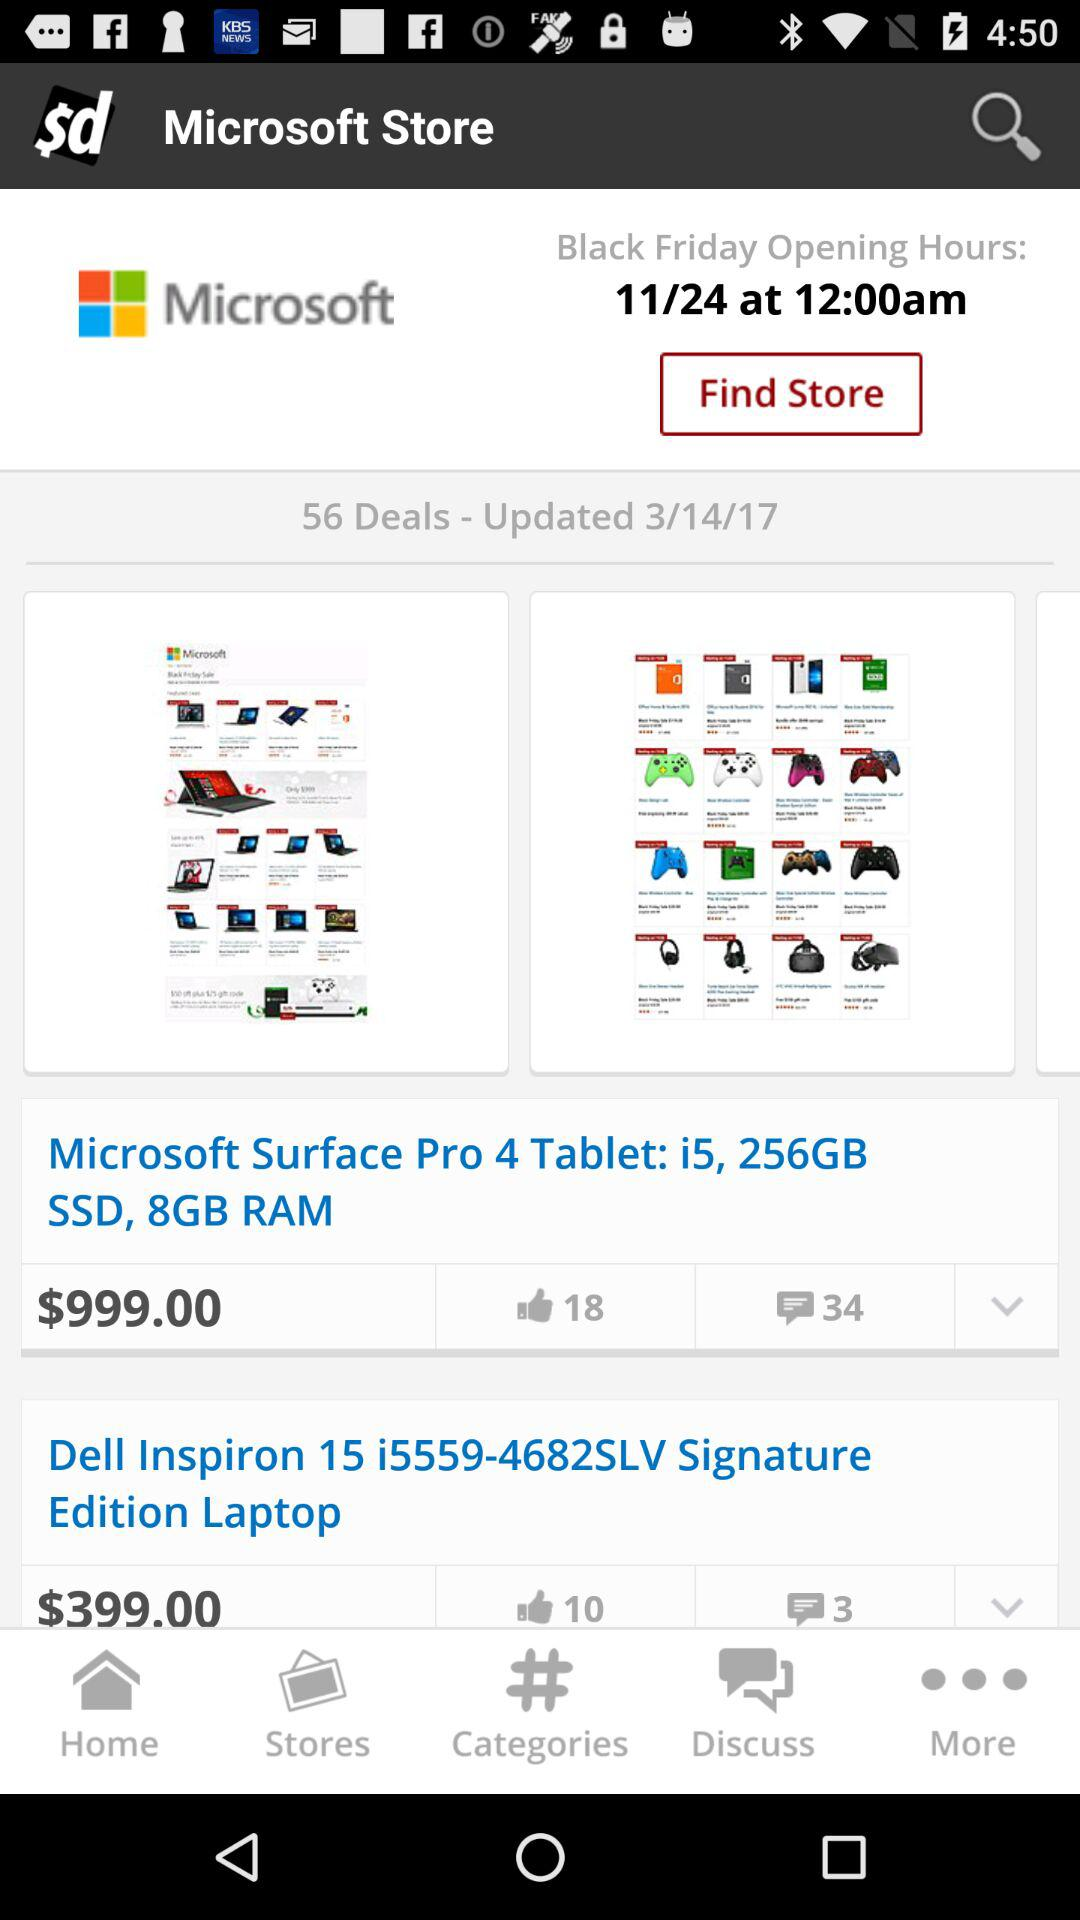What is the price of the "Microsoft Surface Pro 4 Tablet"? The price of the "Microsoft Surface Pro 4 Tablet" is $999.00. 